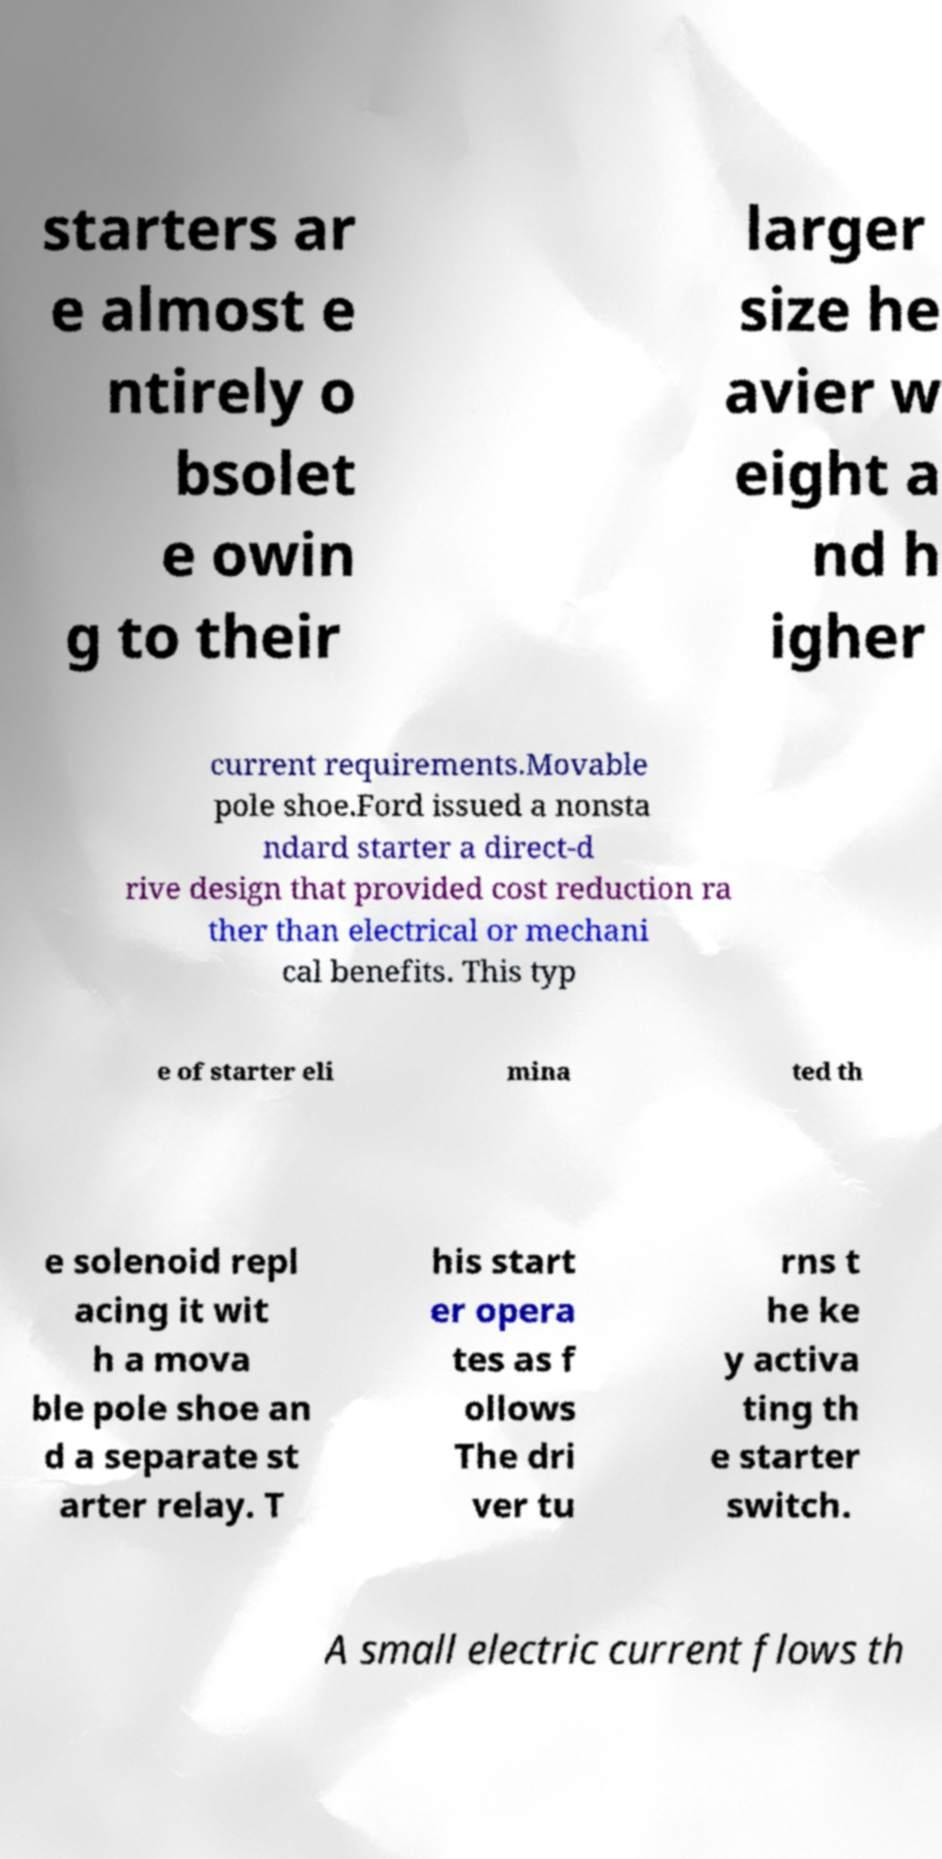Can you read and provide the text displayed in the image?This photo seems to have some interesting text. Can you extract and type it out for me? starters ar e almost e ntirely o bsolet e owin g to their larger size he avier w eight a nd h igher current requirements.Movable pole shoe.Ford issued a nonsta ndard starter a direct-d rive design that provided cost reduction ra ther than electrical or mechani cal benefits. This typ e of starter eli mina ted th e solenoid repl acing it wit h a mova ble pole shoe an d a separate st arter relay. T his start er opera tes as f ollows The dri ver tu rns t he ke y activa ting th e starter switch. A small electric current flows th 